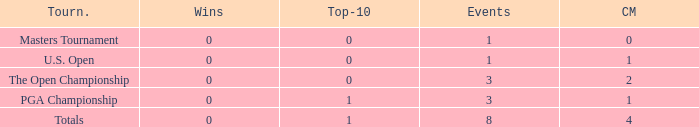For majors with 8 events played and more than 1 made cut, what is the most top-10s recorded? 1.0. 